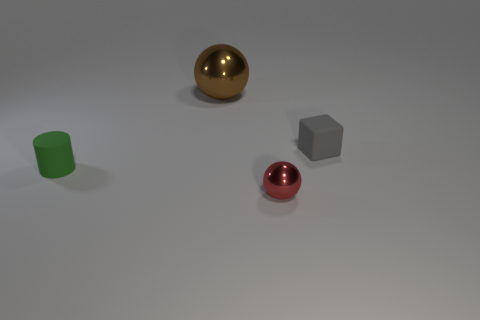Is the color of the small shiny ball the same as the tiny rubber thing that is to the right of the brown metallic object?
Ensure brevity in your answer.  No. Is the number of small yellow blocks greater than the number of green matte cylinders?
Make the answer very short. No. There is another brown object that is the same shape as the small shiny thing; what size is it?
Provide a succinct answer. Large. Are the cube and the big ball that is behind the gray rubber cube made of the same material?
Your answer should be very brief. No. What number of things are either red metallic things or matte cylinders?
Offer a very short reply. 2. There is a metal ball in front of the brown shiny object; does it have the same size as the matte thing to the right of the small red object?
Give a very brief answer. Yes. How many balls are large objects or small green matte objects?
Give a very brief answer. 1. Are there any red metal objects?
Ensure brevity in your answer.  Yes. Is there anything else that has the same shape as the gray thing?
Your answer should be very brief. No. Does the small metallic object have the same color as the cylinder?
Your answer should be compact. No. 